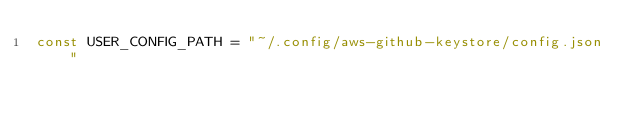<code> <loc_0><loc_0><loc_500><loc_500><_Go_>const USER_CONFIG_PATH = "~/.config/aws-github-keystore/config.json"
</code> 